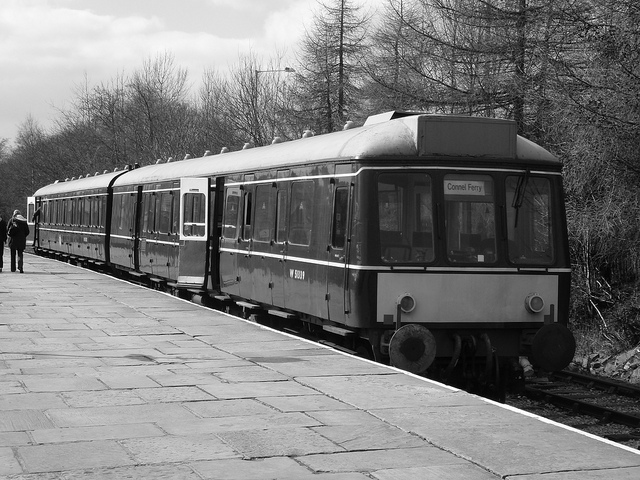What era could this train be from based on its design? This train has a classic design that suggests it's from the late 20th century, likely between the 1960s and 1980s. Its simple, functional aesthetic and the technology visible, such as the lack of modern digital displays, support this estimate. 